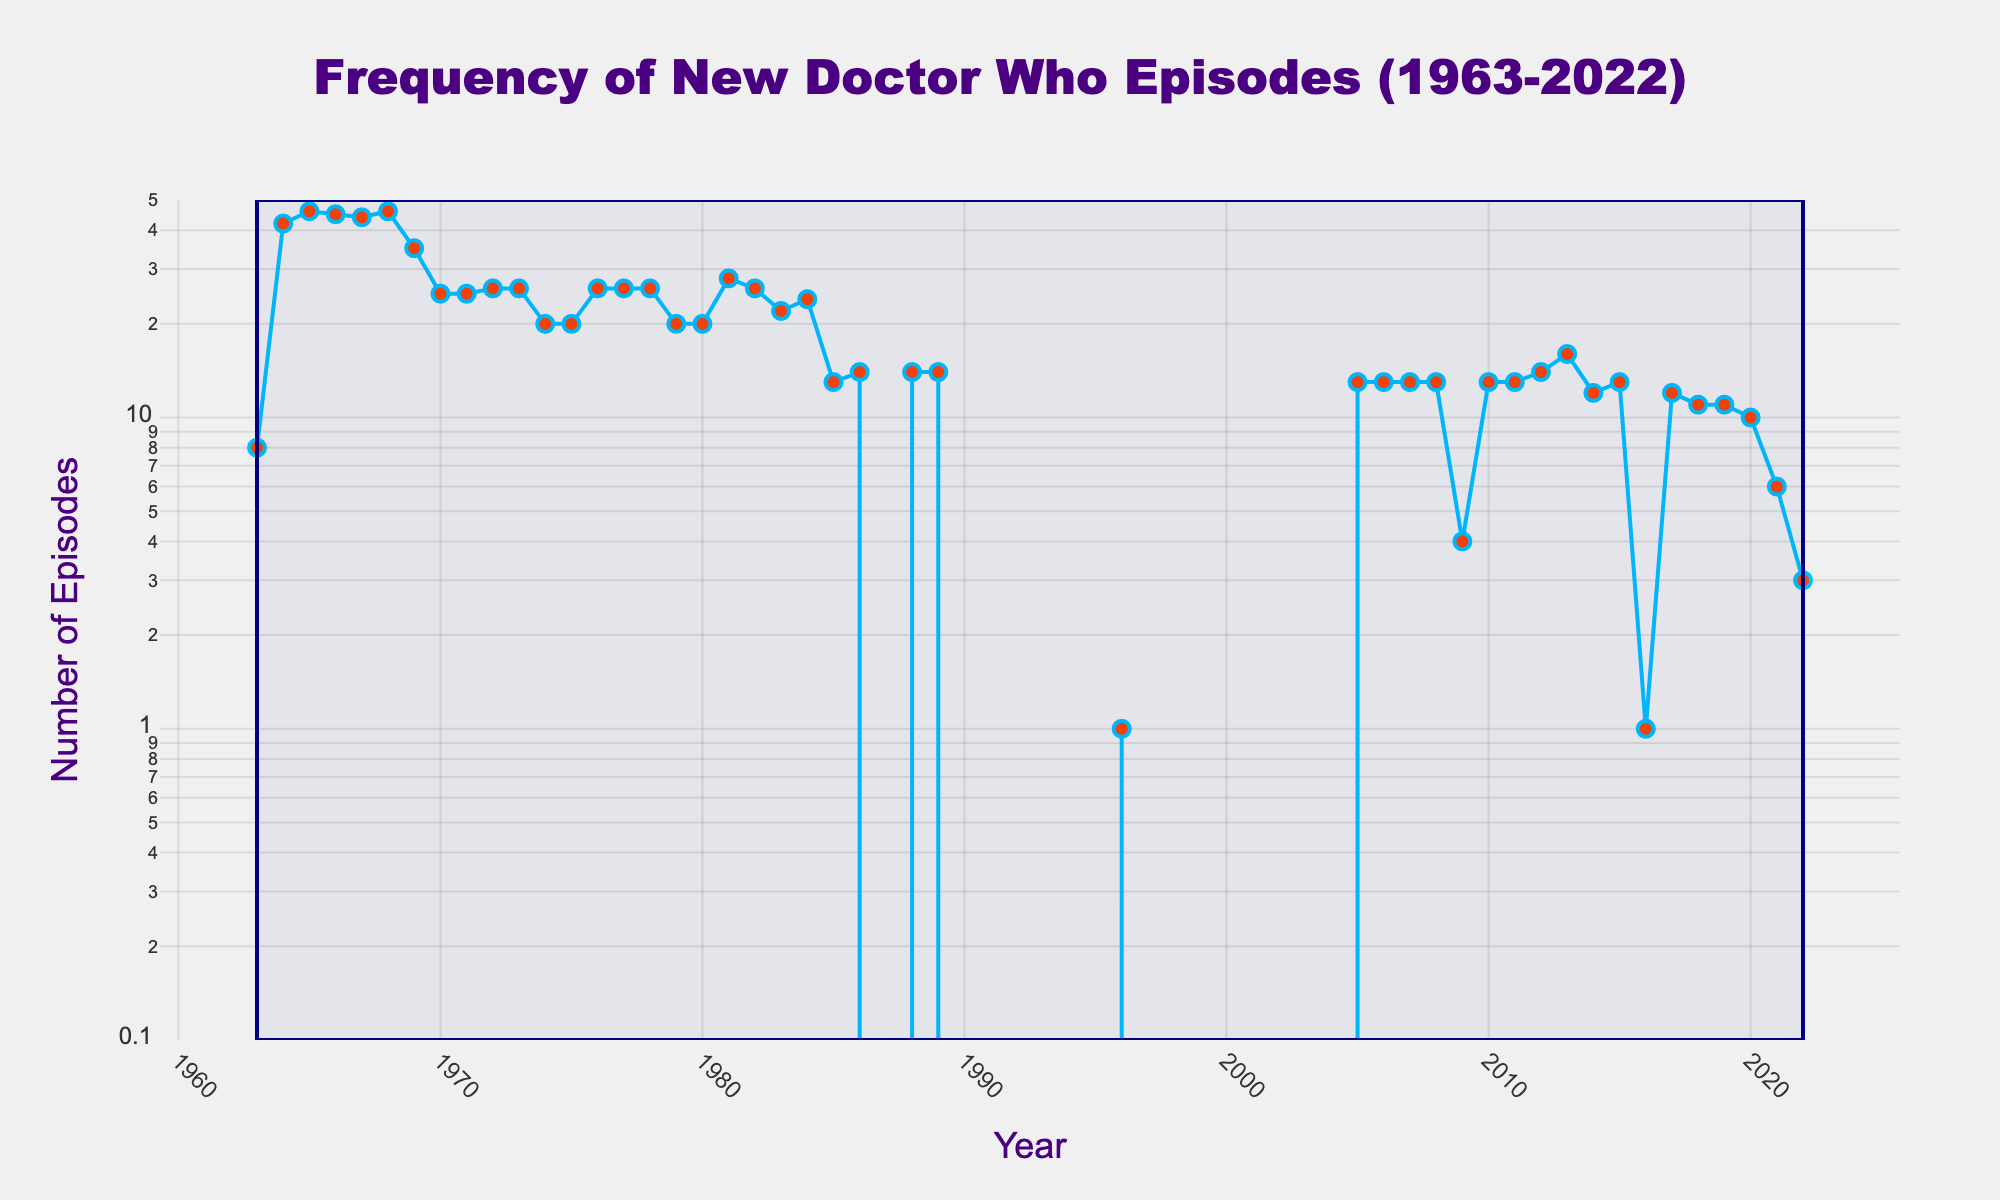How many episodes were released in the debut year of Doctor Who? The title indicates the range from 1963 onwards. By looking at the plot around 1963, we can see the data point representing 8 episodes.
Answer: 8 What year saw the highest number of episodes released, and how many were there? The highest point on the plot can be identified by visually scanning the peaks. The year with the highest peak is 1965, and the data point corresponding to it is 46 episodes.
Answer: 1965, 46 Which year had the most significant drop in the number of episodes compared to the previous year? Identify the steepest downward slope by looking for the sharpest decline between two consecutive years. The steepest drop occurs between 1984 and 1985, from 24 to 13 episodes, a decline of 11 episodes.
Answer: 1985 How many years had zero new episodes released? Count the number of years where the data points fall to zero. The periods are from 1987 to 1989, 1990 to 1995, 1997 to 2003, and 2004, summing up to a total of 16 years.
Answer: 16 years In how many years were 13 episodes released, and which years were they? Identify and count the data points labeled 13. The years are 1985, 2005 to 2008, 2010, 2011, 2015, making it 7 occurrences.
Answer: 7 years (1985, 2005-2008, 2010, 2011, 2015) What was the average number of episodes released per year during the 1970s? Sum the episode counts from 1970 to 1979 (25+25+26+26+20+20+26+26+26+20=230), and then divide by the number of years (10).
Answer: 23 episodes Were there any years after the revival in 2005 when only one episode was released? Check the period from 2005 onwards. The plot shows one episode in 2016, confirming it.
Answer: Yes, 2016 What is the range of the y-axis, and why is it chosen to be on a log scale? The y-axis ranges from approximately 0.1 to 50, as indicated by the grid lines. The log scale helps to better visualize the variations across years with small and large counts of episodes.
Answer: ~0.1 to 50, to better visualize variations Which decade had the most consistent number of episodes released per year? Consistency can be seen as relatively stable plot lines. The 1970s plot line looks consistent, with data points ranging narrowly between 20 and 26.
Answer: 1970s 